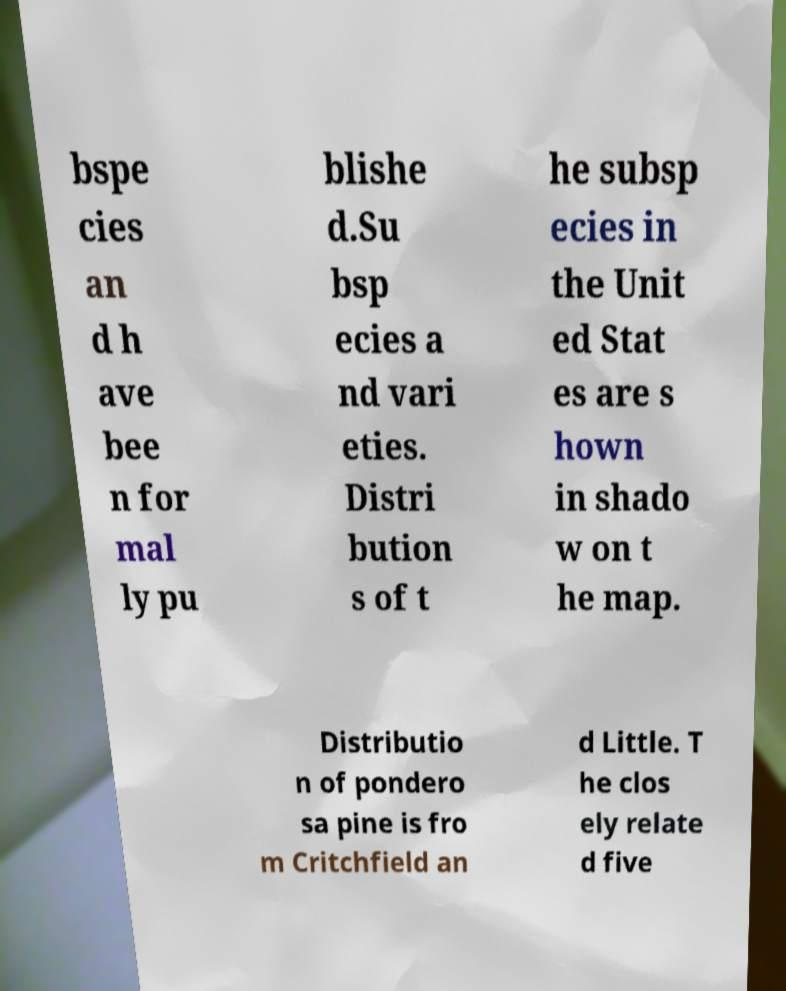Can you read and provide the text displayed in the image?This photo seems to have some interesting text. Can you extract and type it out for me? bspe cies an d h ave bee n for mal ly pu blishe d.Su bsp ecies a nd vari eties. Distri bution s of t he subsp ecies in the Unit ed Stat es are s hown in shado w on t he map. Distributio n of pondero sa pine is fro m Critchfield an d Little. T he clos ely relate d five 